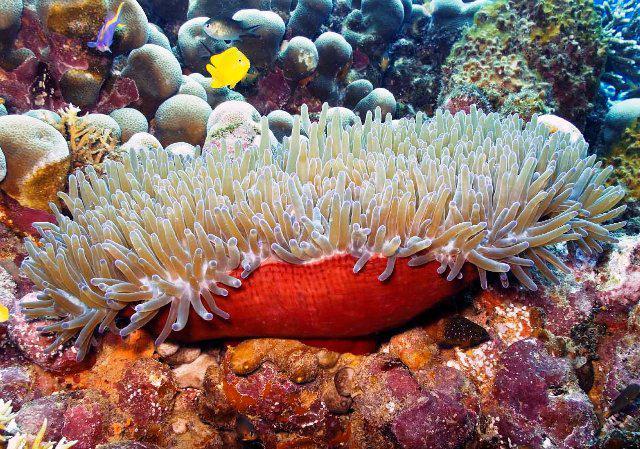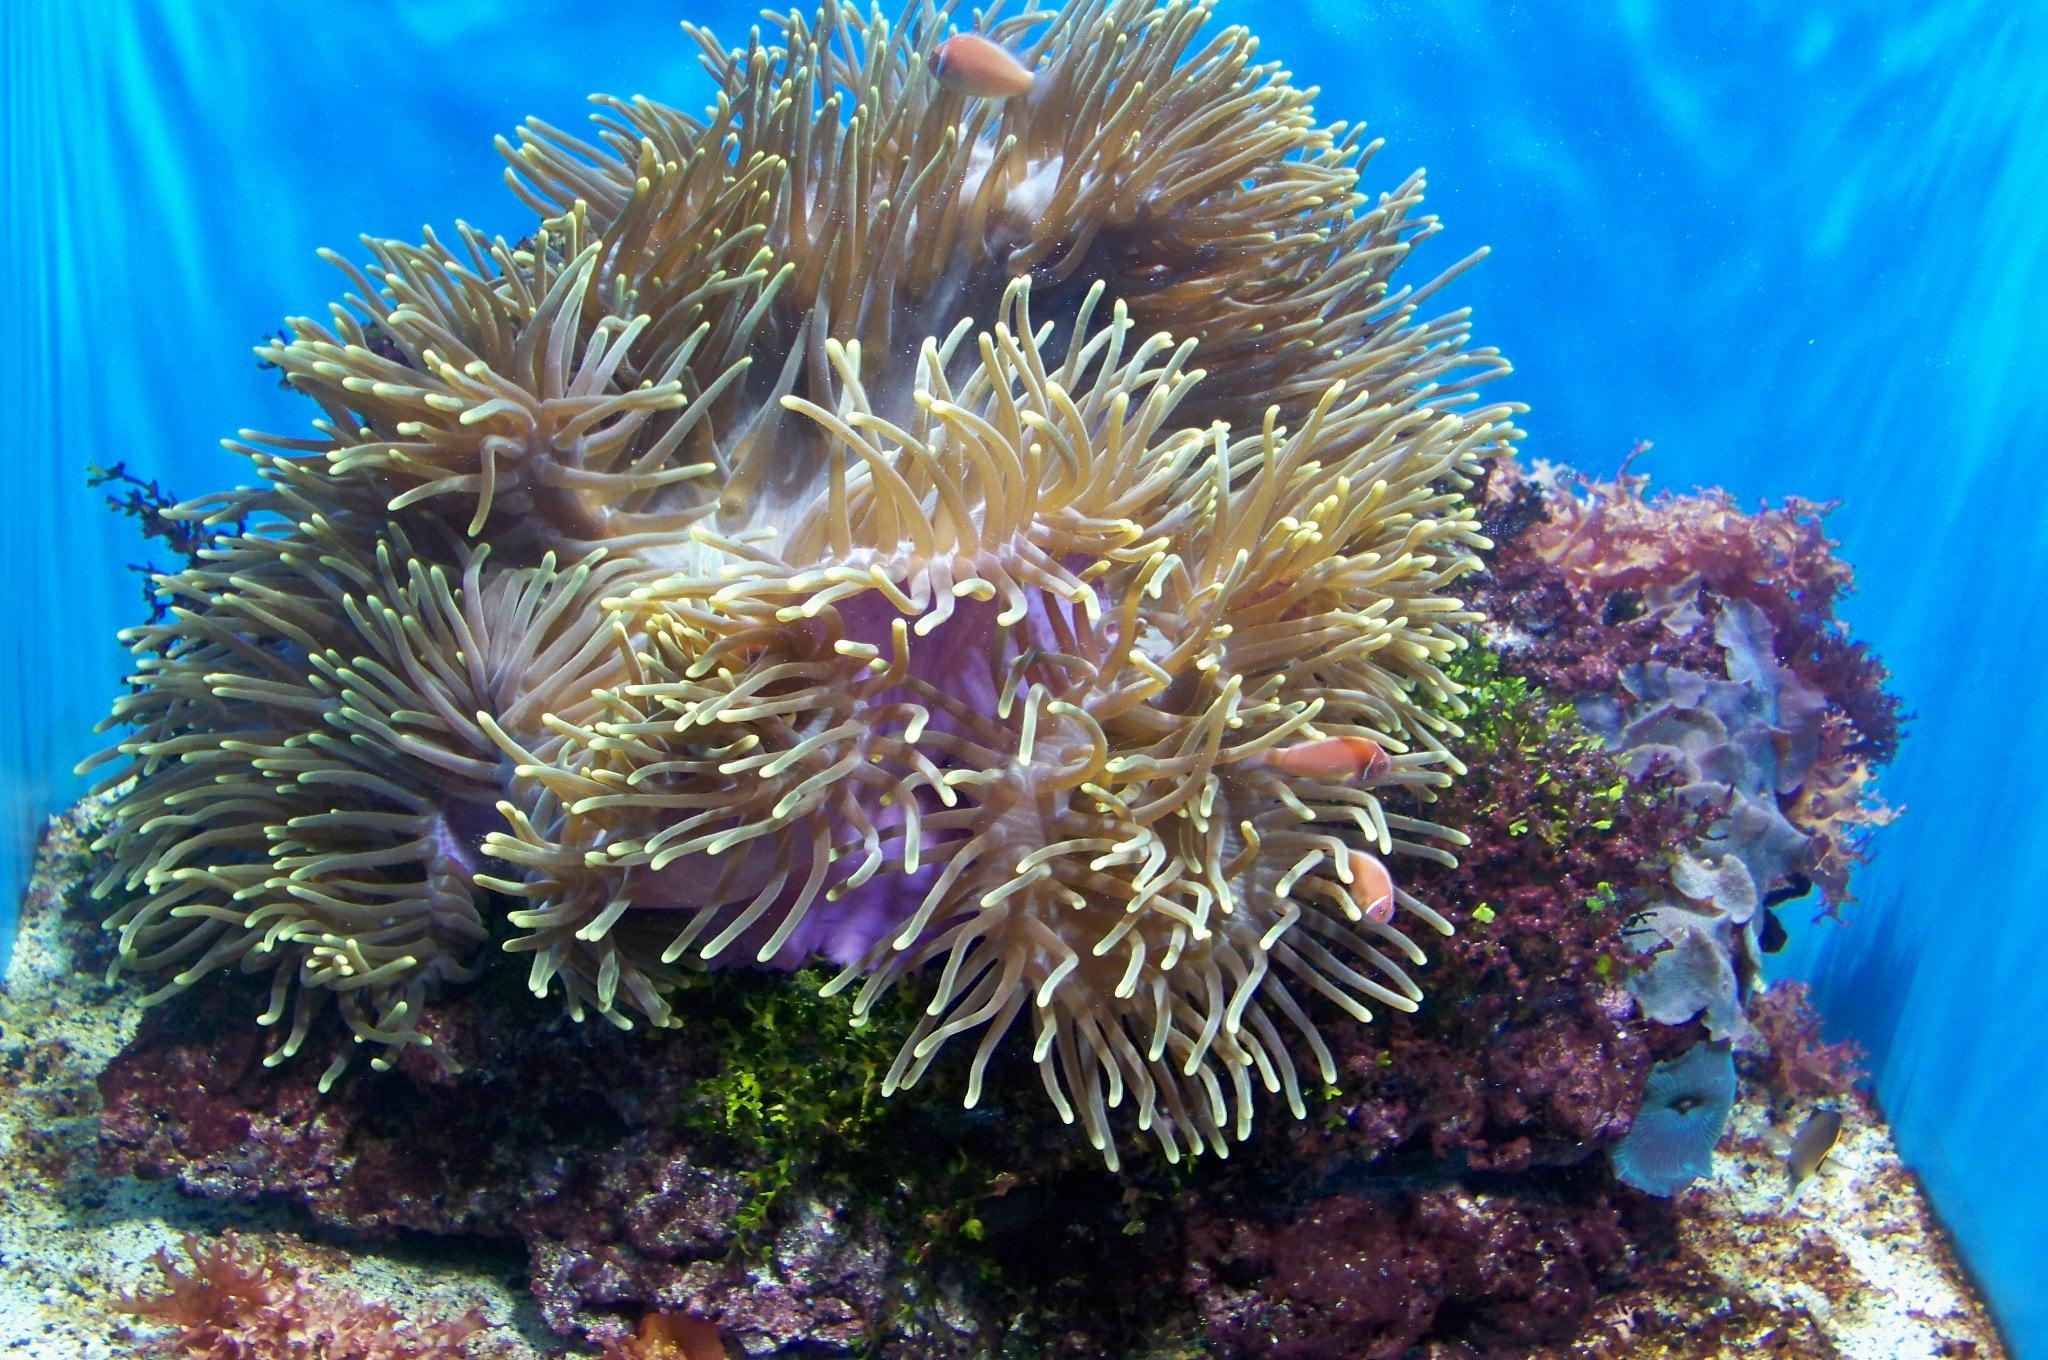The first image is the image on the left, the second image is the image on the right. For the images displayed, is the sentence "Only one of the images contains clown fish." factually correct? Answer yes or no. No. The first image is the image on the left, the second image is the image on the right. Assess this claim about the two images: "A bright yellow fish is swimming in the water in the image on the left.". Correct or not? Answer yes or no. Yes. 